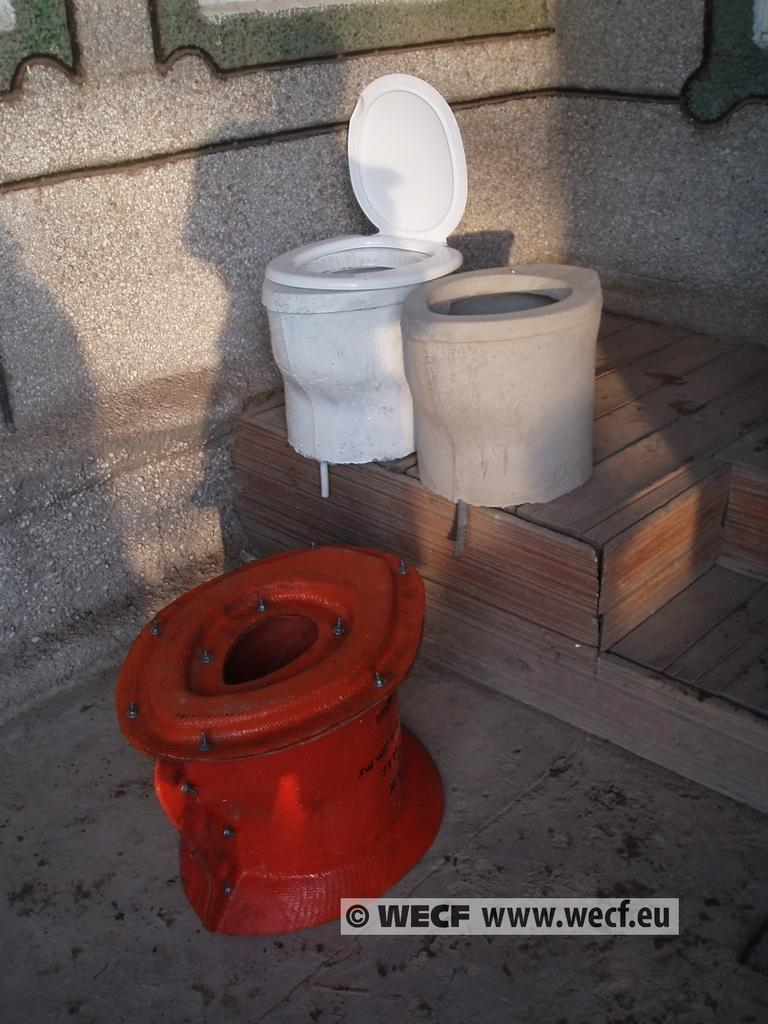<image>
Present a compact description of the photo's key features. Three old toilets, one red, white and beige from the source WECF. 